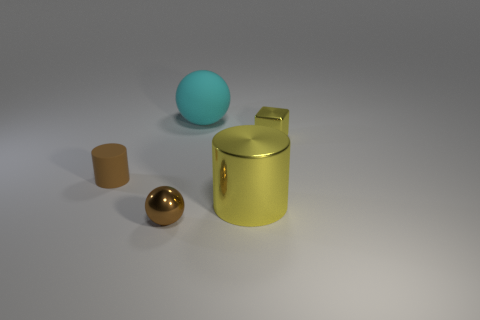Add 2 large gray matte spheres. How many objects exist? 7 Subtract all balls. How many objects are left? 3 Subtract 0 green balls. How many objects are left? 5 Subtract all large cylinders. Subtract all small matte objects. How many objects are left? 3 Add 1 small yellow metal things. How many small yellow metal things are left? 2 Add 1 big gray things. How many big gray things exist? 1 